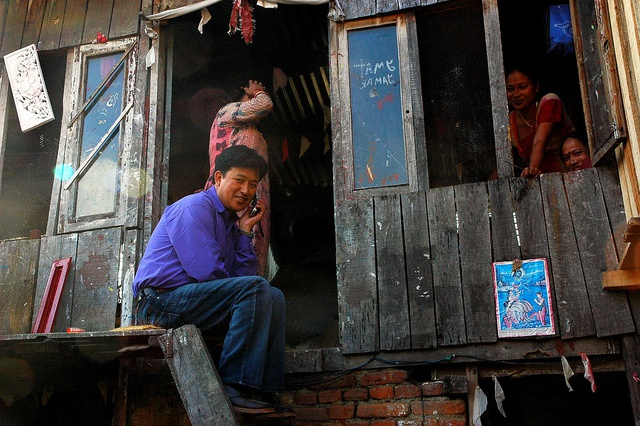Describe the objects in this image and their specific colors. I can see people in brown, black, navy, maroon, and gray tones, people in brown, black, and maroon tones, people in brown, black, maroon, and lightpink tones, people in brown, black, and maroon tones, and cell phone in brown, black, gray, and darkgray tones in this image. 